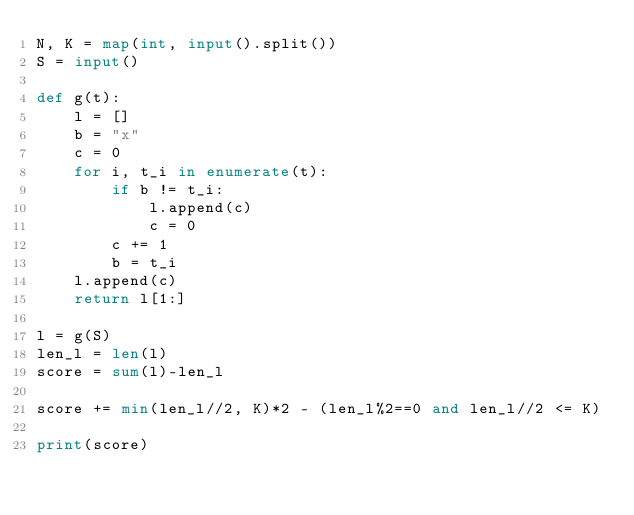Convert code to text. <code><loc_0><loc_0><loc_500><loc_500><_Python_>N, K = map(int, input().split())
S = input()

def g(t):
    l = []
    b = "x"
    c = 0
    for i, t_i in enumerate(t):
        if b != t_i:
            l.append(c)
            c = 0
        c += 1
        b = t_i
    l.append(c)
    return l[1:]

l = g(S)
len_l = len(l)
score = sum(l)-len_l

score += min(len_l//2, K)*2 - (len_l%2==0 and len_l//2 <= K)

print(score)</code> 